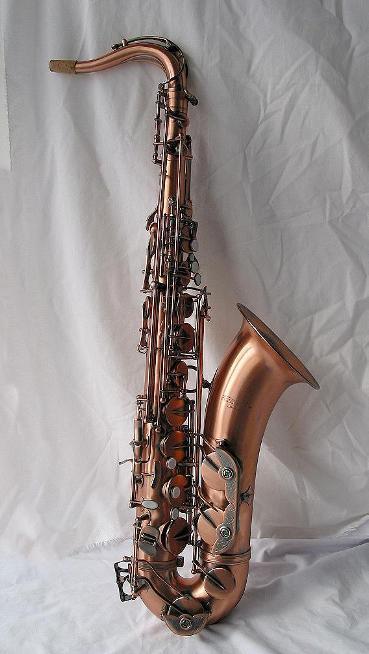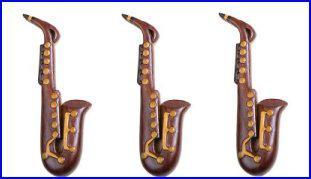The first image is the image on the left, the second image is the image on the right. Examine the images to the left and right. Is the description "There are at least four instruments in total shown." accurate? Answer yes or no. Yes. The first image is the image on the left, the second image is the image on the right. Considering the images on both sides, is "One image contains three or more saxophones." valid? Answer yes or no. Yes. 